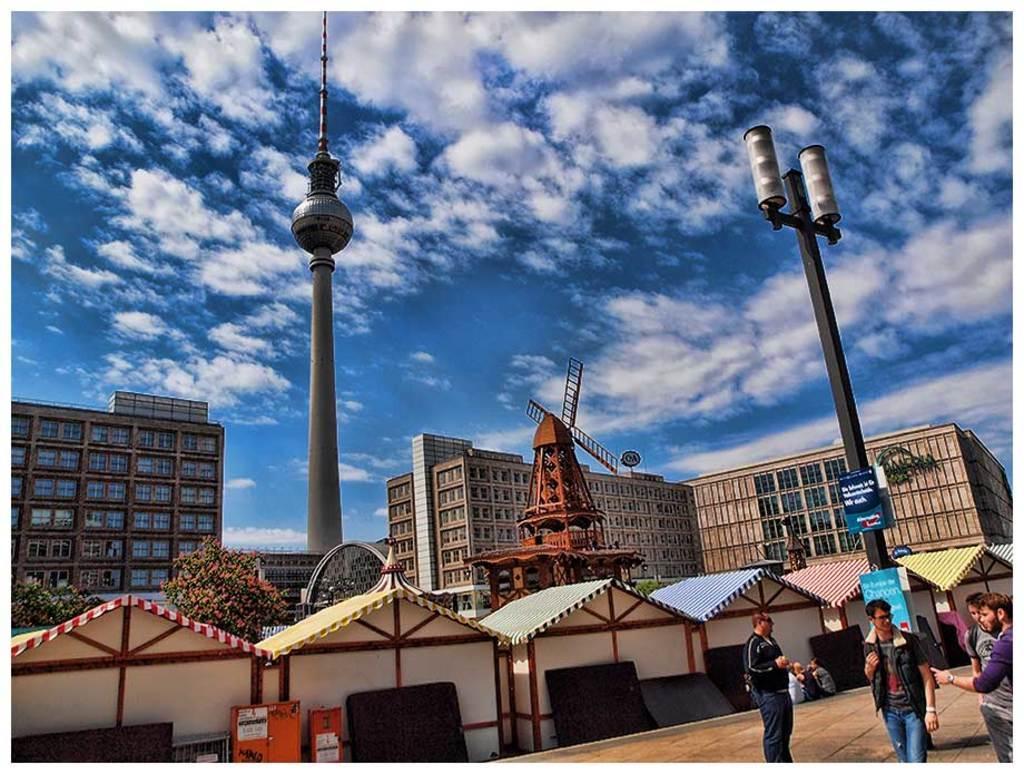How would you summarize this image in a sentence or two? In this image I can see on the right side few people are there. In the middle there are buildings and it looks like a windmill house, at the top it is the sky. 